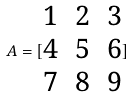<formula> <loc_0><loc_0><loc_500><loc_500>A = [ \begin{matrix} 1 & 2 & 3 \\ 4 & 5 & 6 \\ 7 & 8 & 9 \end{matrix} ]</formula> 